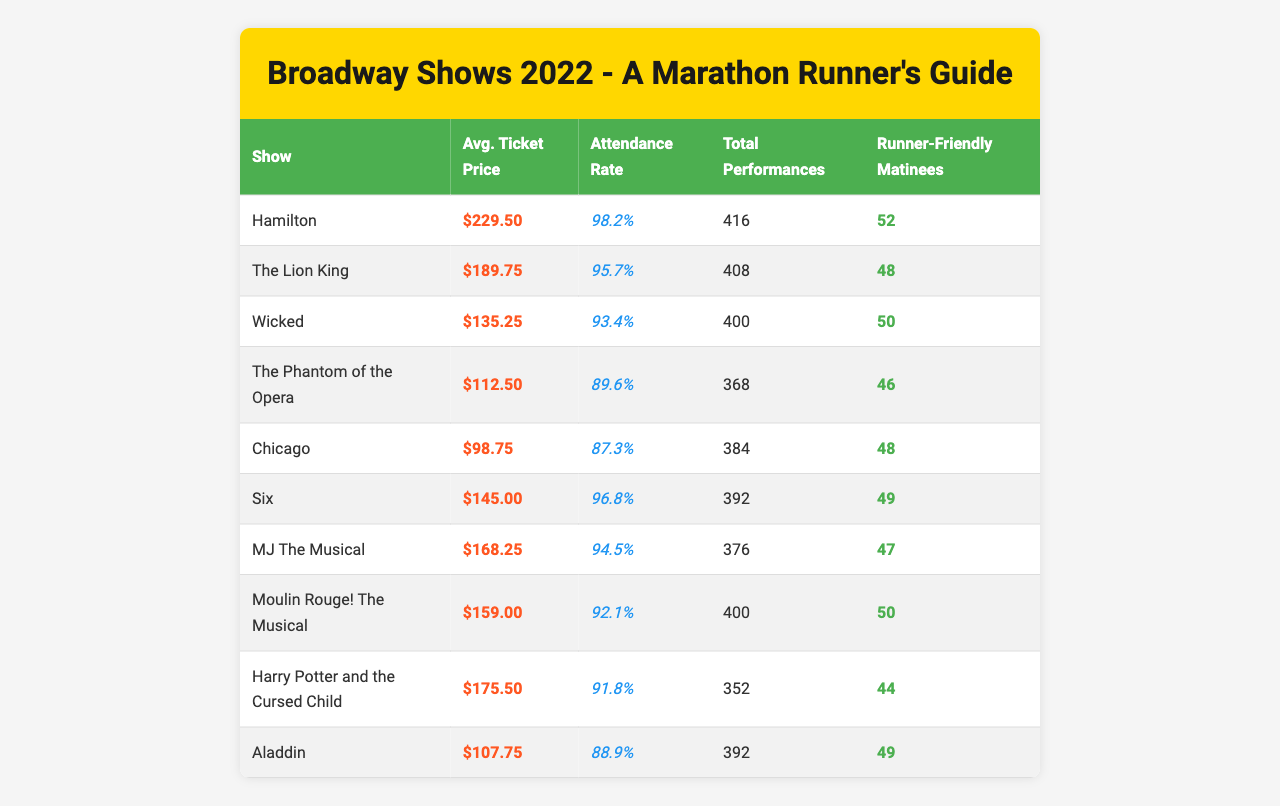What is the average ticket price for "Wicked"? The table lists the average ticket price for "Wicked" as $135.25.
Answer: $135.25 How many total performances were there for "The Lion King"? The table shows that "The Lion King" had a total of 408 performances.
Answer: 408 Which show had the highest attendance rate? By comparing the attendance rates, "Hamilton" at 98.2% has the highest attendance rate among the shows listed.
Answer: Hamilton What is the average attendance rate for shows that have more than 400 total performances? The shows with over 400 performances are "Hamilton" (98.2%), "The Lion King" (95.7%), "Wicked" (93.4%), "Six" (96.8%), and "Moulin Rouge! The Musical" (92.1%). Adding these rates gives 98.2 + 95.7 + 93.4 + 96.8 + 92.1 = 476.2. Dividing by 5 gives an average of 95.24%.
Answer: 95.24% Which show has the most runner-friendly matinees? The table indicates that "Hamilton" has the most runner-friendly matinees with a total of 52.
Answer: 52 Is "Harry Potter and the Cursed Child" priced higher than "Chicago"? "Harry Potter and the Cursed Child" has an average ticket price of $175.50, while "Chicago" has a price of $98.75. Therefore, it is true that "Harry Potter and the Cursed Child" is priced higher.
Answer: Yes What is the total attendance rate for all shows combined? First, we total the attendance rates: 98.2 + 95.7 + 93.4 + 89.6 + 87.3 + 96.8 + 94.5 + 92.1 + 91.8 + 88.9 = 918.3. To find the average attendance rate, divide the total by the number of shows (10): 918.3 / 10 = 91.83%.
Answer: 91.83% If you were to summarize, how many shows had an attendance rate above 95%? The shows with an attendance rate above 95% are "Hamilton" (98.2%), "The Lion King" (95.7%), and "Six" (96.8%). There are three shows that meet this criterion.
Answer: 3 What is the difference in average ticket price between "MJ The Musical" and "Moulin Rouge! The Musical"? "MJ The Musical" is priced at $168.25, while "Moulin Rouge! The Musical" costs $159. The difference is $168.25 - $159 = $9.25.
Answer: $9.25 